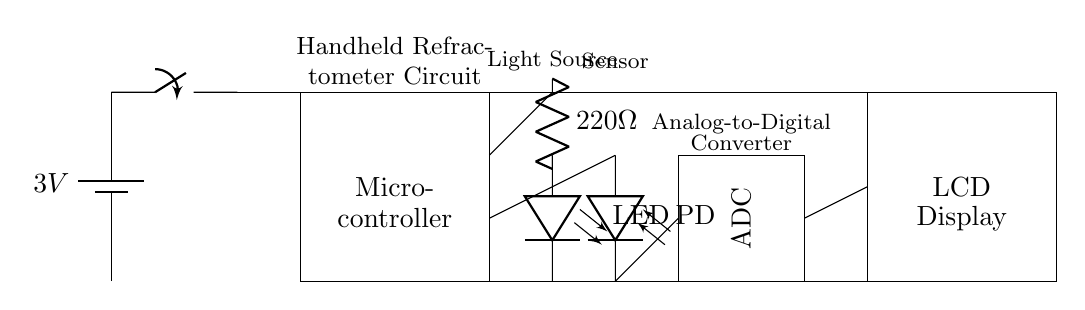What is the voltage of the battery in this circuit? The voltage of the battery is indicated as 3V, which is labeled on the battery symbol in the circuit diagram.
Answer: 3V What type of component is connected to the light source? The component connected to the light source is a resistor labeled as 220 ohms. This can be seen connected to the LED symbol in the diagram.
Answer: 220 ohm resistor What is the function of the photodiode in this circuit? The photodiode serves as a sensor for detecting light intensity, particularly from the LED light source. It converts light into an electrical signal, which is essential for measuring sugar content.
Answer: Sensor What does ADC stand for? ADC stands for Analog-to-Digital Converter, which converts the analog signal from the photodiode into a digital signal that can be processed by the microcontroller.
Answer: Analog-to-Digital Converter Why is a switch included in this circuit diagram? The switch allows the user to turn the circuit on or off, thus controlling power to the entire system. This is essential in battery-operated devices to conserve energy when not in use.
Answer: Power control How are the microcontroller and LCD display connected? The microcontroller and LCD display are connected by a direct wire, which allows the microcontroller to send processed data to the LCD for visualization, as indicated by the connection lines in the circuit.
Answer: Direct wire connection 